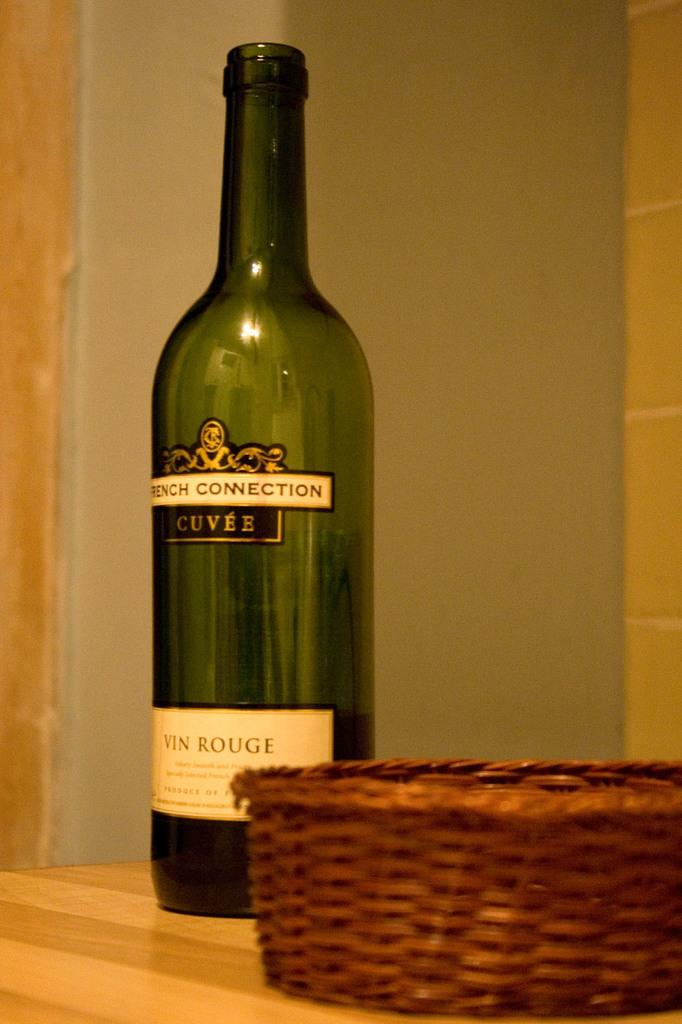<image>
Give a short and clear explanation of the subsequent image. Bottle with a label that says "Cuvee" on it. 